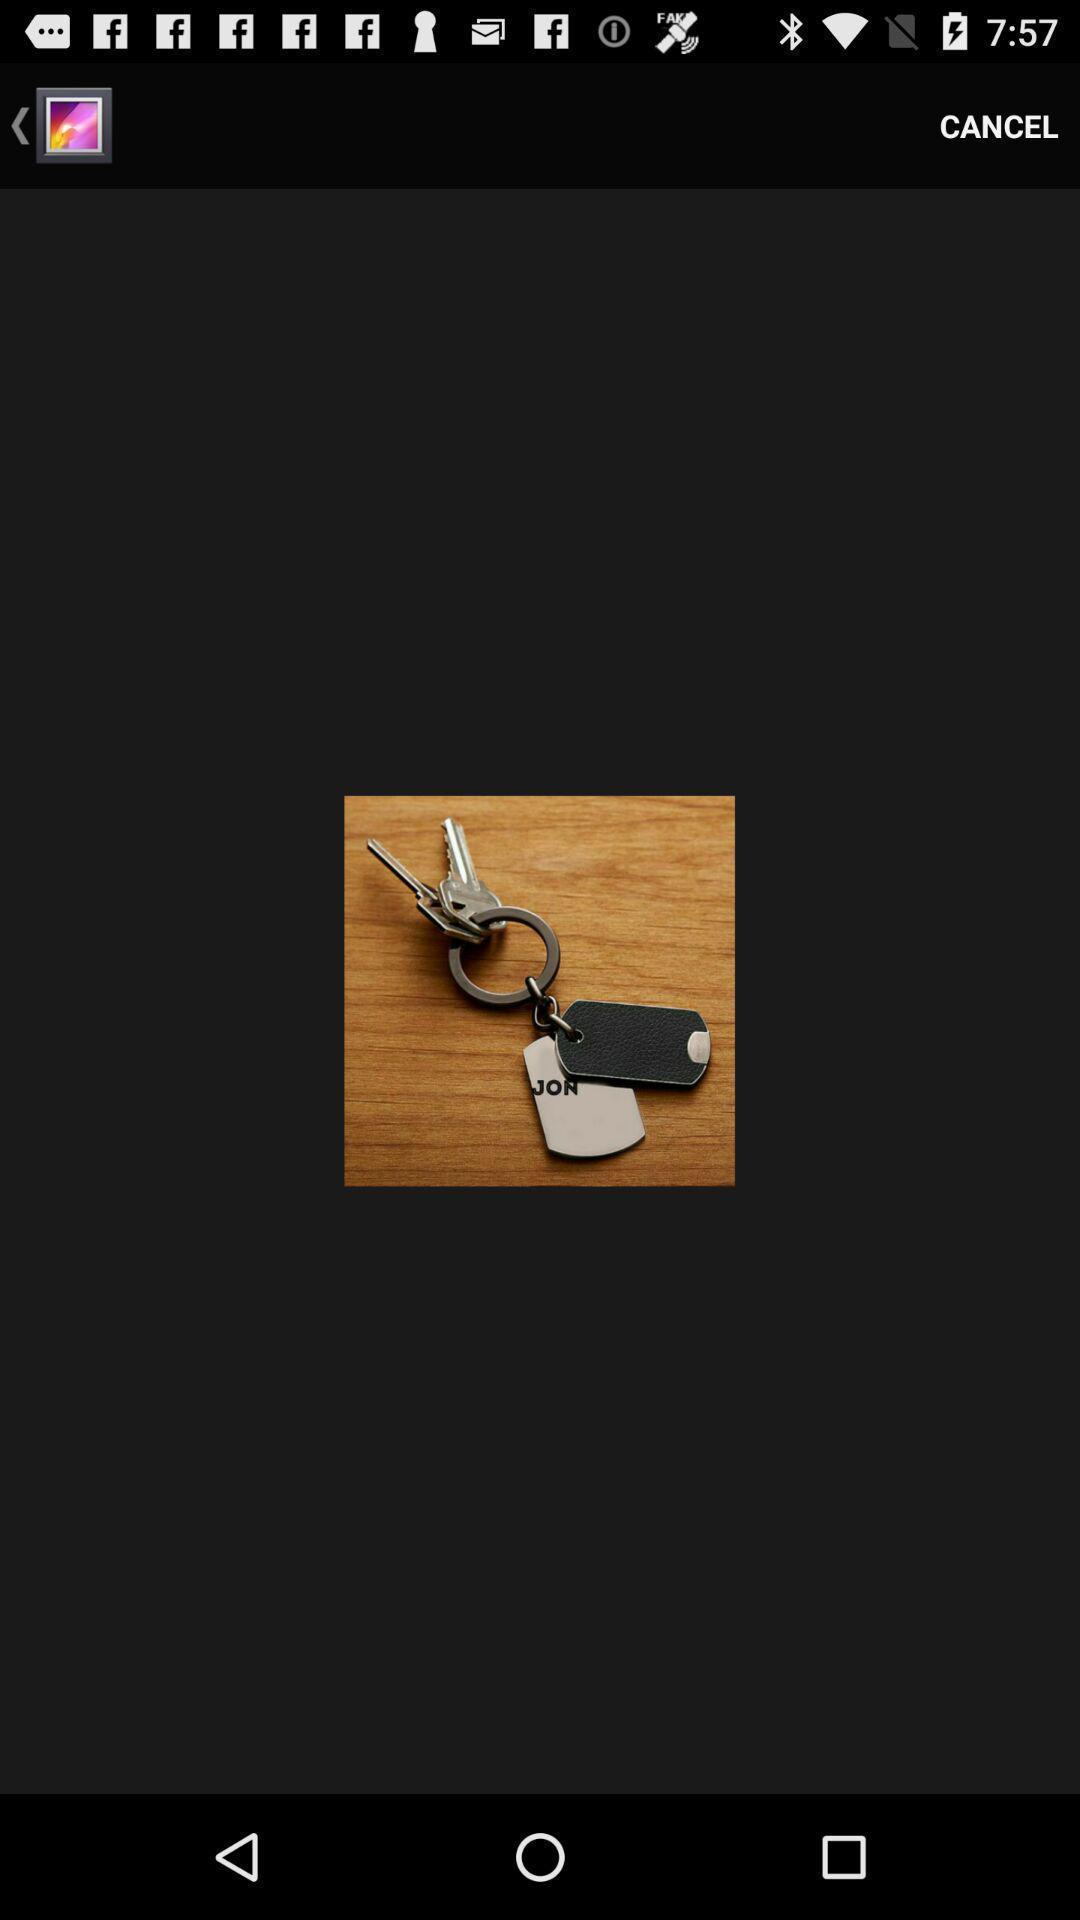Provide a description of this screenshot. Screen shows an image of keys. 